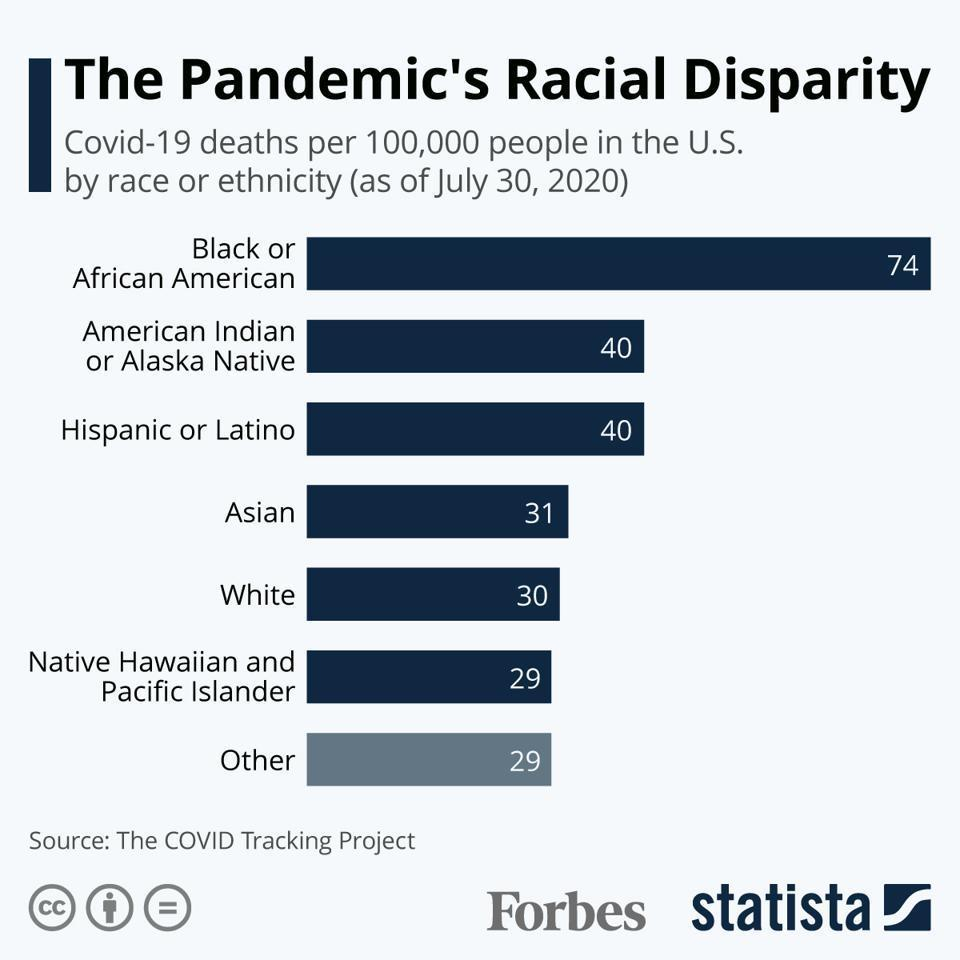Who has died more due to Covid-19?
Answer the question with a short phrase. Black or African American 